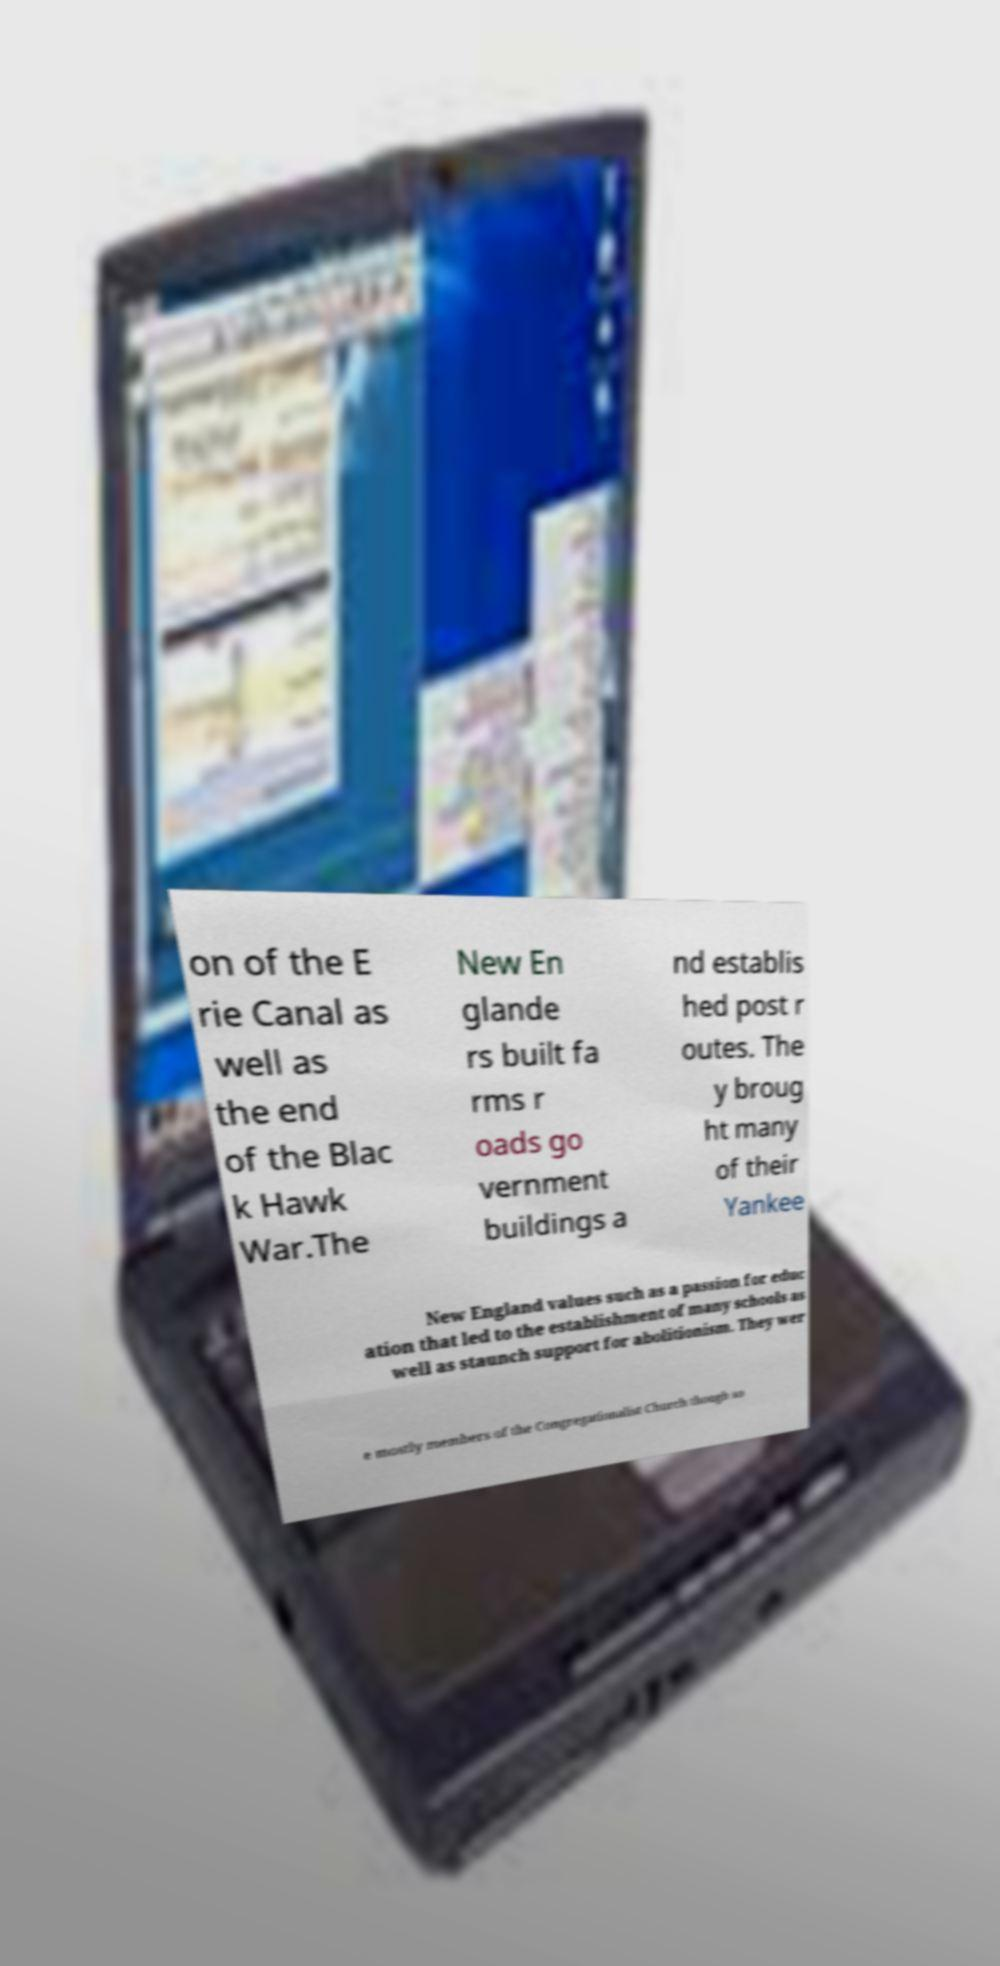Please read and relay the text visible in this image. What does it say? on of the E rie Canal as well as the end of the Blac k Hawk War.The New En glande rs built fa rms r oads go vernment buildings a nd establis hed post r outes. The y broug ht many of their Yankee New England values such as a passion for educ ation that led to the establishment of many schools as well as staunch support for abolitionism. They wer e mostly members of the Congregationalist Church though so 